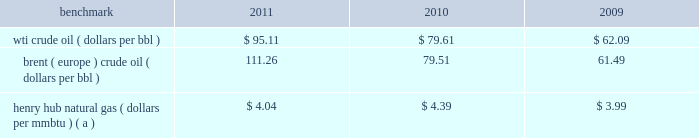Item 7 .
Management 2019s discussion and analysis of financial condition and results of operations we are an international energy company with operations in the u.s. , canada , africa , the middle east and europe .
Our operations are organized into three reportable segments : 2022 e&p which explores for , produces and markets liquid hydrocarbons and natural gas on a worldwide basis .
2022 osm which mines , extracts and transports bitumen from oil sands deposits in alberta , canada , and upgrades the bitumen to produce and market synthetic crude oil and vacuum gas oil .
2022 ig which produces and markets products manufactured from natural gas , such as lng and methanol , in eg .
Certain sections of management 2019s discussion and analysis of financial condition and results of operations include forward-looking statements concerning trends or events potentially affecting our business .
These statements typically contain words such as 201canticipates , 201d 201cbelieves , 201d 201cestimates , 201d 201cexpects , 201d 201ctargets , 201d 201cplans , 201d 201cprojects , 201d 201ccould , 201d 201cmay , 201d 201cshould , 201d 201cwould 201d or similar words indicating that future outcomes are uncertain .
In accordance with 201csafe harbor 201d provisions of the private securities litigation reform act of 1995 , these statements are accompanied by cautionary language identifying important factors , though not necessarily all such factors , which could cause future outcomes to differ materially from those set forth in forward-looking statements .
For additional risk factors affecting our business , see item 1a .
Risk factors in this annual report on form 10-k .
Management 2019s discussion and analysis of financial condition and results of operations should be read in conjunction with the information under item 1 .
Business , item 1a .
Risk factors and item 8 .
Financial statements and supplementary data found in this annual report on form 10-k .
Spin-off downstream business on june 30 , 2011 , the spin-off of marathon 2019s downstream business was completed , creating two independent energy companies : marathon oil and mpc .
Marathon shareholders at the close of business on the record date of june 27 , 2011 received one share of mpc common stock for every two shares of marathon common stock held .
Fractional shares of mpc common stock were not distributed and any fractional share of mpc common stock otherwise issuable to a marathon shareholder was sold in the open market on such shareholder 2019s behalf , and such shareholder received a cash payment with respect to that fractional share .
A private letter tax ruling received in june 2011 from the irs affirmed the tax-free nature of the spin-off .
Activities related to the downstream business have been treated as discontinued operations in all periods presented in this annual report on form 10-k ( see item 8 .
Financial statements and supplementary data 2014note 3 to the consolidated financial statements for additional information ) .
Overview 2013 market conditions exploration and production prevailing prices for the various grades of crude oil and natural gas that we produce significantly impact our revenues and cash flows .
Prices of crude oil have been volatile in recent years .
In 2011 , crude prices increased over 2010 levels , with increases in brent averages outstripping those in wti .
During much of 2010 , both wti and brent crude oil monthly average prices remained in the $ 75 to $ 85 per barrel range .
Crude oil prices reached a low of $ 33.98 in february 2009 , following global demand declines in an economic recession , but recovered quickly ending 2009 at $ 79.36 .
The table lists benchmark crude oil and natural gas price annual averages for the past three years. .
Wti crude oil ( dollars per bbl ) $ 95.11 $ 79.61 $ 62.09 brent ( europe ) crude oil ( dollars per bbl ) 111.26 79.51 61.49 henry hub natural gas ( dollars per mmbtu ) ( a ) $ 4.04 $ 4.39 $ 3.99 ( a ) settlement date average .
Our u.s .
Crude oil production was approximately 58 percent sour in 2011 and 68 percent in 2010 .
Sour crude contains more sulfur than light sweet wti does .
Sour crude oil also tends to be heavier than light sweet crude oil and sells at a discount to light sweet crude oil because of higher refining costs and lower refined product values .
Our international crude oil production is relatively sweet and is generally sold in relation to the brent crude benchmark .
The differential between wti and brent average prices widened significantly in 2011 to $ 16.15 in comparison to differentials of less than $ 1.00 in 2010 and 2009. .
By how much did the brent crude oil benchmark increase from 2010 to 2011? 
Computations: ((111.26 - 79.51) / 79.51)
Answer: 0.39932. 